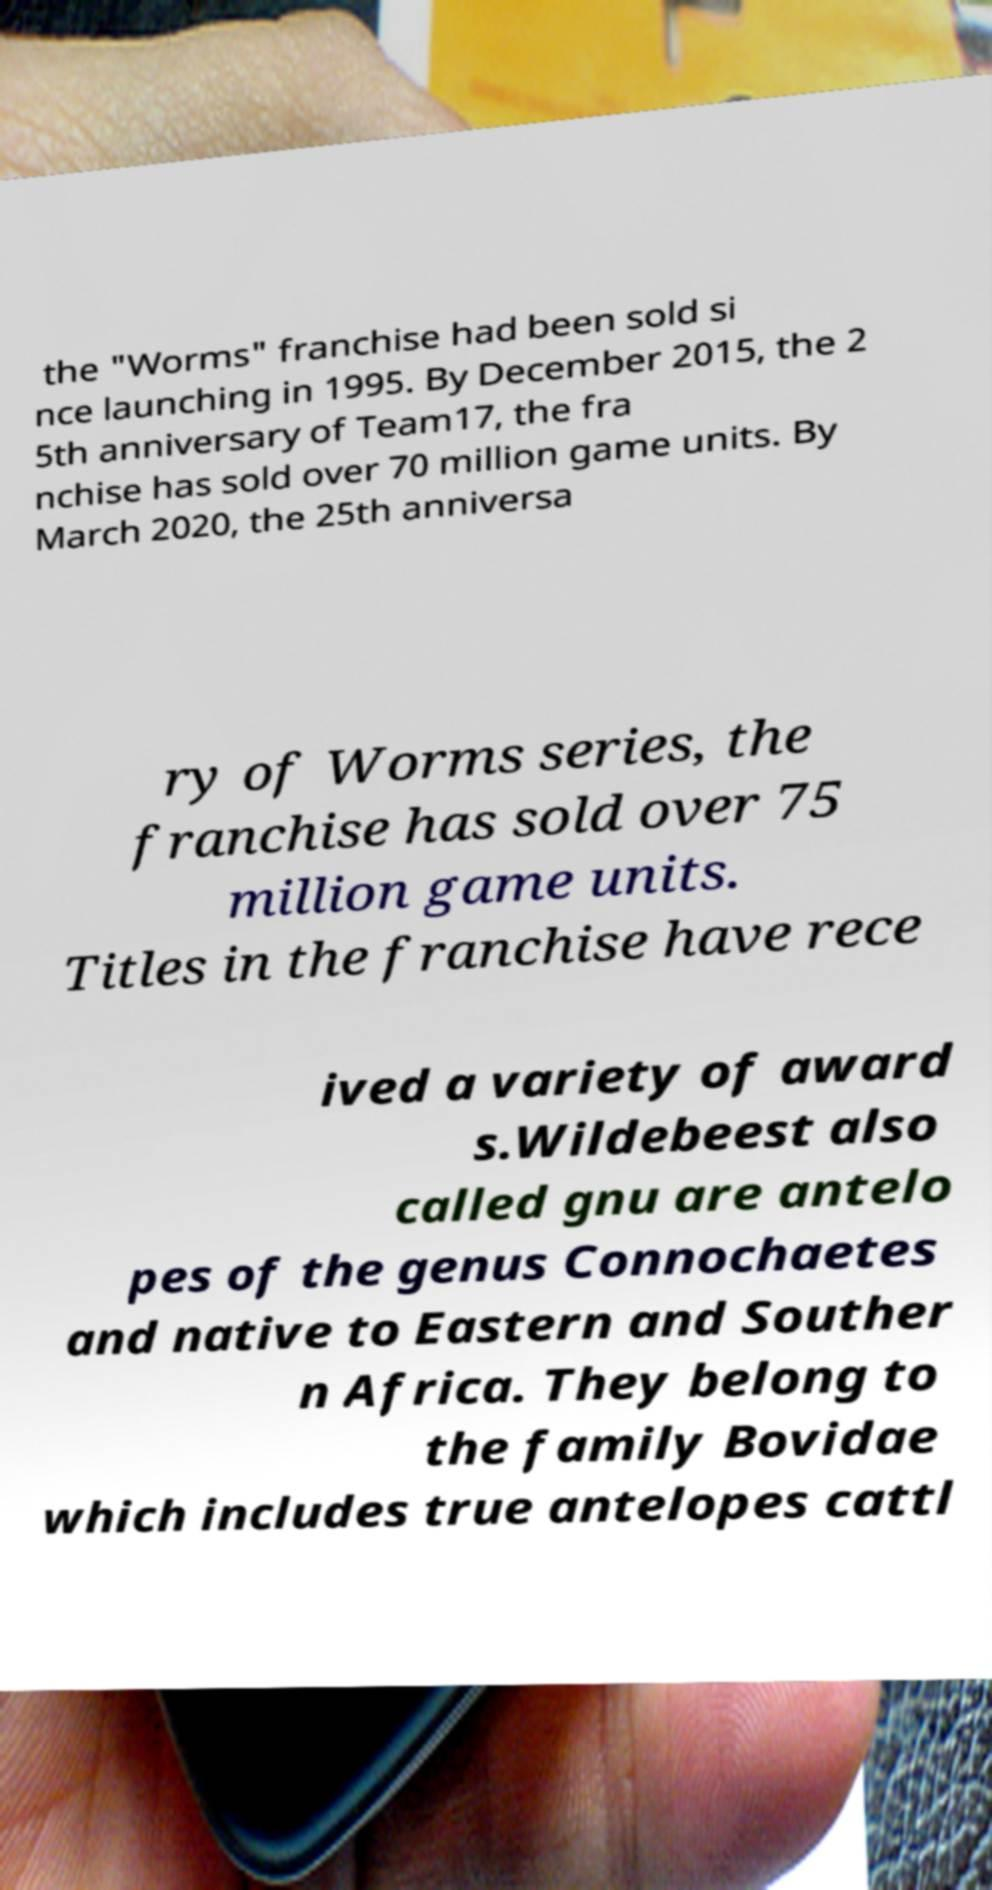I need the written content from this picture converted into text. Can you do that? the "Worms" franchise had been sold si nce launching in 1995. By December 2015, the 2 5th anniversary of Team17, the fra nchise has sold over 70 million game units. By March 2020, the 25th anniversa ry of Worms series, the franchise has sold over 75 million game units. Titles in the franchise have rece ived a variety of award s.Wildebeest also called gnu are antelo pes of the genus Connochaetes and native to Eastern and Souther n Africa. They belong to the family Bovidae which includes true antelopes cattl 